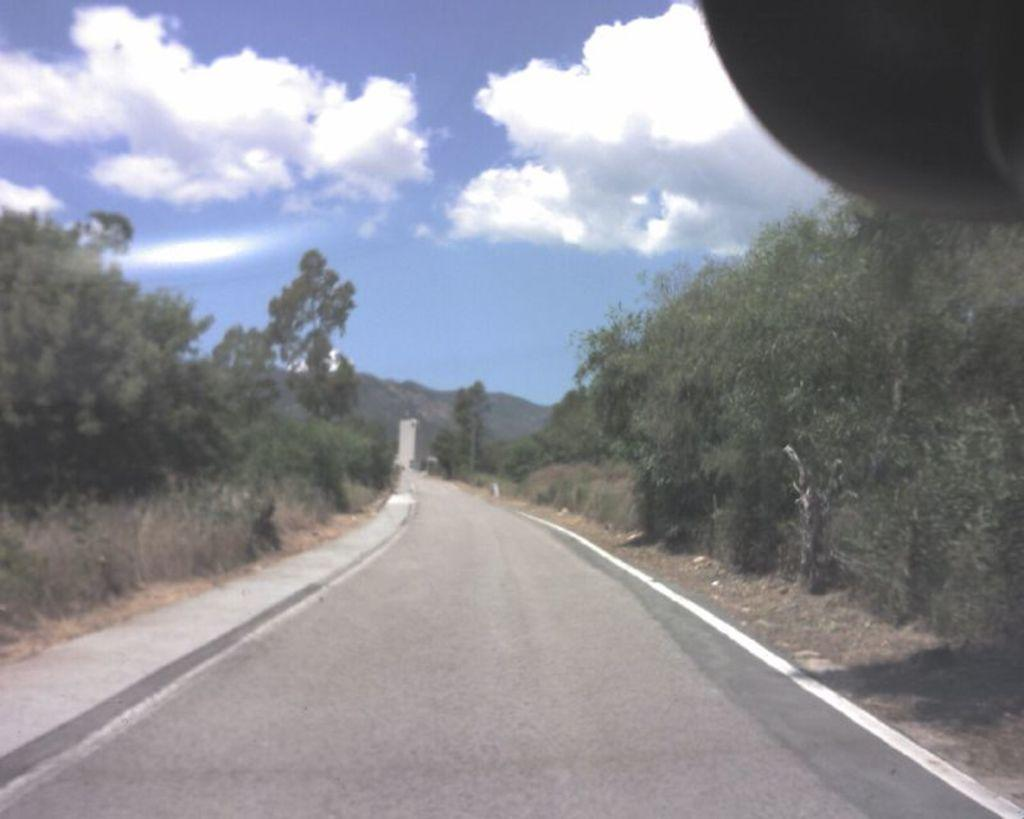What is the main feature of the image? There is a road in the image. What can be seen on the sides of the road? Trees are present on the sides of the road. What is visible in the background of the image? The sky is visible in the background of the image. What can be observed in the sky? Clouds are present in the sky. How many coasts can be seen in the image? There are no coasts present in the image; it features a road with trees on the sides and a sky with clouds. What type of base is visible in the image? There is no base present in the image; it features a road, trees, and a sky with clouds. 